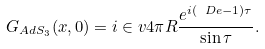<formula> <loc_0><loc_0><loc_500><loc_500>G _ { A d S _ { 3 } } ( x , 0 ) = i \in v { 4 \pi R } \frac { e ^ { i ( \ D e - 1 ) \tau } } { \sin \tau } .</formula> 